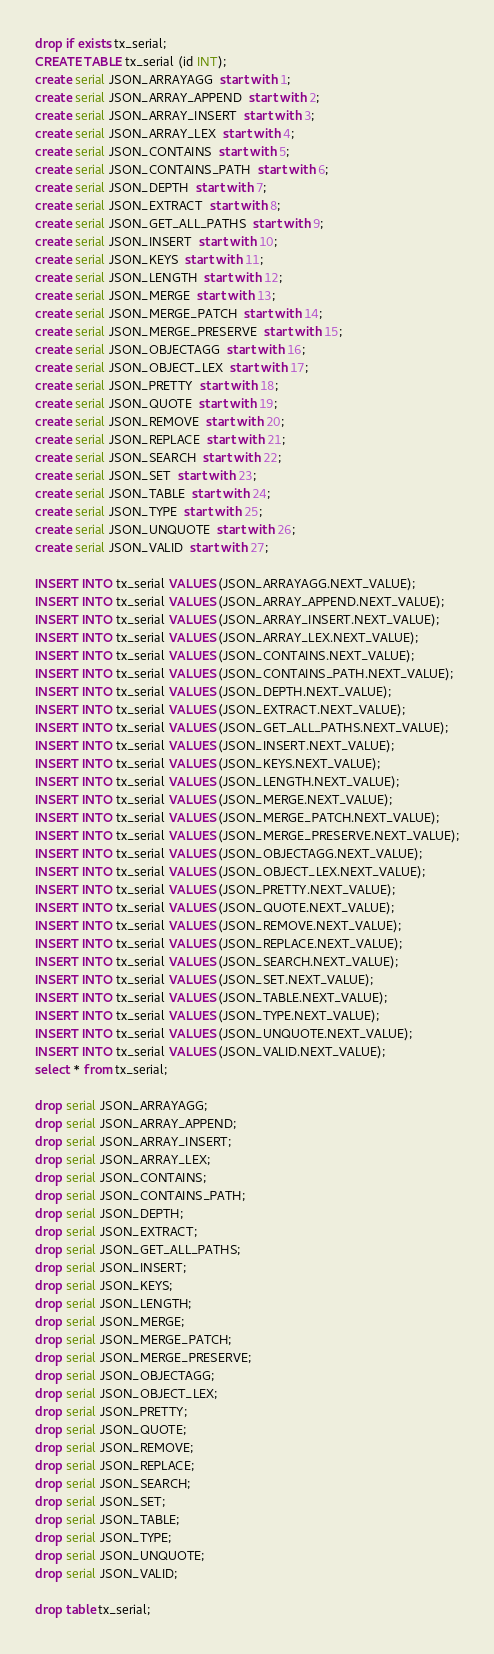<code> <loc_0><loc_0><loc_500><loc_500><_SQL_>drop if exists tx_serial;
CREATE TABLE tx_serial (id INT);
create serial JSON_ARRAYAGG  start with 1;    
create serial JSON_ARRAY_APPEND  start with 2;      
create serial JSON_ARRAY_INSERT  start with 3;  
create serial JSON_ARRAY_LEX  start with 4;     
create serial JSON_CONTAINS  start with 5;      
create serial JSON_CONTAINS_PATH  start with 6; 
create serial JSON_DEPTH  start with 7;         
create serial JSON_EXTRACT  start with 8;       
create serial JSON_GET_ALL_PATHS  start with 9; 
create serial JSON_INSERT  start with 10;        
create serial JSON_KEYS  start with 11;          
create serial JSON_LENGTH  start with 12;        
create serial JSON_MERGE  start with 13;         
create serial JSON_MERGE_PATCH  start with 14;   
create serial JSON_MERGE_PRESERVE  start with 15;
create serial JSON_OBJECTAGG  start with 16;     
create serial JSON_OBJECT_LEX  start with 17;    
create serial JSON_PRETTY  start with 18;        
create serial JSON_QUOTE  start with 19;         
create serial JSON_REMOVE  start with 20;        
create serial JSON_REPLACE  start with 21;       
create serial JSON_SEARCH  start with 22;        
create serial JSON_SET  start with 23;           
create serial JSON_TABLE  start with 24;         
create serial JSON_TYPE  start with 25;          
create serial JSON_UNQUOTE  start with 26;       
create serial JSON_VALID  start with 27;         

INSERT INTO tx_serial VALUES (JSON_ARRAYAGG.NEXT_VALUE);      
INSERT INTO tx_serial VALUES (JSON_ARRAY_APPEND.NEXT_VALUE);  
INSERT INTO tx_serial VALUES (JSON_ARRAY_INSERT.NEXT_VALUE);  
INSERT INTO tx_serial VALUES (JSON_ARRAY_LEX.NEXT_VALUE);     
INSERT INTO tx_serial VALUES (JSON_CONTAINS.NEXT_VALUE);      
INSERT INTO tx_serial VALUES (JSON_CONTAINS_PATH.NEXT_VALUE); 
INSERT INTO tx_serial VALUES (JSON_DEPTH.NEXT_VALUE);         
INSERT INTO tx_serial VALUES (JSON_EXTRACT.NEXT_VALUE);       
INSERT INTO tx_serial VALUES (JSON_GET_ALL_PATHS.NEXT_VALUE); 
INSERT INTO tx_serial VALUES (JSON_INSERT.NEXT_VALUE);        
INSERT INTO tx_serial VALUES (JSON_KEYS.NEXT_VALUE);          
INSERT INTO tx_serial VALUES (JSON_LENGTH.NEXT_VALUE);        
INSERT INTO tx_serial VALUES (JSON_MERGE.NEXT_VALUE);         
INSERT INTO tx_serial VALUES (JSON_MERGE_PATCH.NEXT_VALUE);   
INSERT INTO tx_serial VALUES (JSON_MERGE_PRESERVE.NEXT_VALUE);
INSERT INTO tx_serial VALUES (JSON_OBJECTAGG.NEXT_VALUE);     
INSERT INTO tx_serial VALUES (JSON_OBJECT_LEX.NEXT_VALUE);    
INSERT INTO tx_serial VALUES (JSON_PRETTY.NEXT_VALUE);        
INSERT INTO tx_serial VALUES (JSON_QUOTE.NEXT_VALUE);         
INSERT INTO tx_serial VALUES (JSON_REMOVE.NEXT_VALUE);        
INSERT INTO tx_serial VALUES (JSON_REPLACE.NEXT_VALUE);       
INSERT INTO tx_serial VALUES (JSON_SEARCH.NEXT_VALUE);        
INSERT INTO tx_serial VALUES (JSON_SET.NEXT_VALUE);           
INSERT INTO tx_serial VALUES (JSON_TABLE.NEXT_VALUE);         
INSERT INTO tx_serial VALUES (JSON_TYPE.NEXT_VALUE);          
INSERT INTO tx_serial VALUES (JSON_UNQUOTE.NEXT_VALUE);       
INSERT INTO tx_serial VALUES (JSON_VALID.NEXT_VALUE);         
select * from tx_serial;
       
drop serial JSON_ARRAYAGG;      
drop serial JSON_ARRAY_APPEND;  
drop serial JSON_ARRAY_INSERT;  
drop serial JSON_ARRAY_LEX;     
drop serial JSON_CONTAINS;      
drop serial JSON_CONTAINS_PATH; 
drop serial JSON_DEPTH;         
drop serial JSON_EXTRACT;       
drop serial JSON_GET_ALL_PATHS; 
drop serial JSON_INSERT;        
drop serial JSON_KEYS;          
drop serial JSON_LENGTH;        
drop serial JSON_MERGE;         
drop serial JSON_MERGE_PATCH;   
drop serial JSON_MERGE_PRESERVE;
drop serial JSON_OBJECTAGG;     
drop serial JSON_OBJECT_LEX;    
drop serial JSON_PRETTY;        
drop serial JSON_QUOTE;         
drop serial JSON_REMOVE;        
drop serial JSON_REPLACE;       
drop serial JSON_SEARCH;        
drop serial JSON_SET;           
drop serial JSON_TABLE;         
drop serial JSON_TYPE;          
drop serial JSON_UNQUOTE;       
drop serial JSON_VALID; 
        
drop table tx_serial;
</code> 